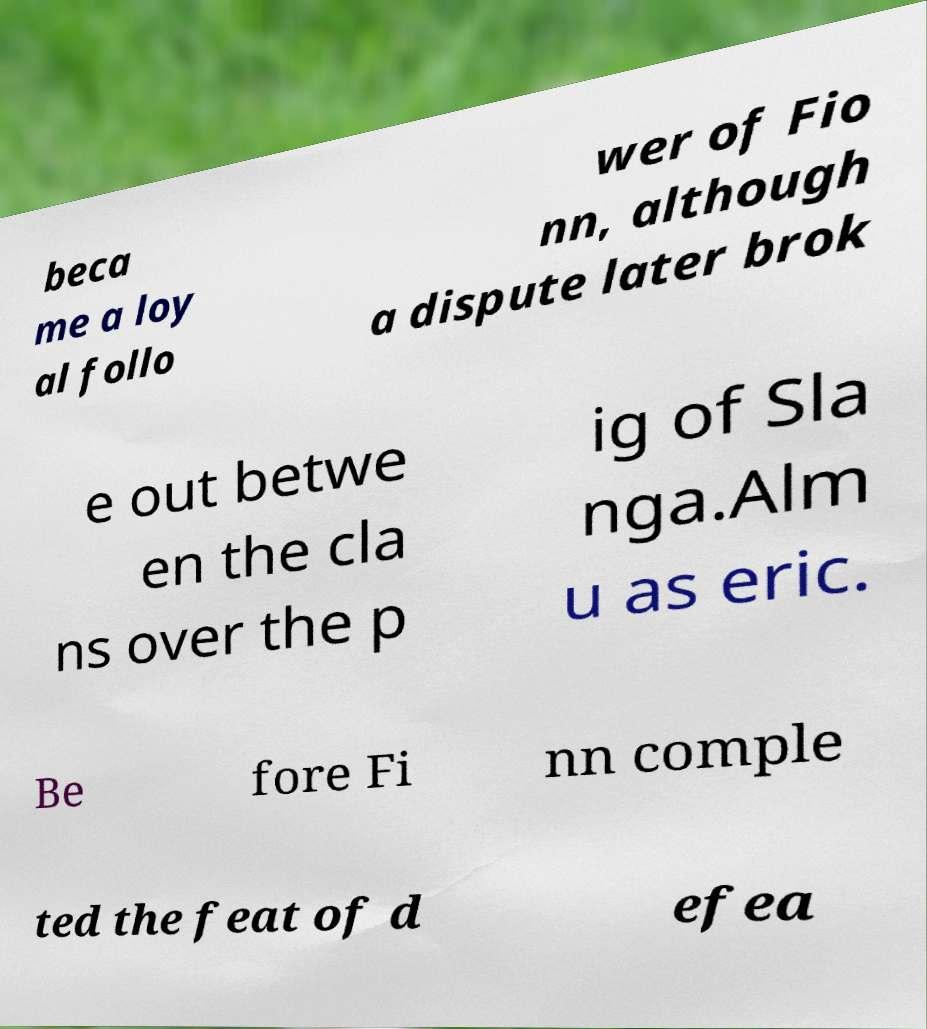Could you extract and type out the text from this image? beca me a loy al follo wer of Fio nn, although a dispute later brok e out betwe en the cla ns over the p ig of Sla nga.Alm u as eric. Be fore Fi nn comple ted the feat of d efea 